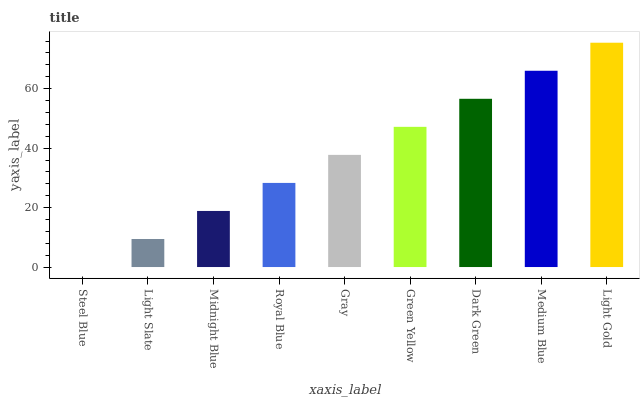Is Steel Blue the minimum?
Answer yes or no. Yes. Is Light Gold the maximum?
Answer yes or no. Yes. Is Light Slate the minimum?
Answer yes or no. No. Is Light Slate the maximum?
Answer yes or no. No. Is Light Slate greater than Steel Blue?
Answer yes or no. Yes. Is Steel Blue less than Light Slate?
Answer yes or no. Yes. Is Steel Blue greater than Light Slate?
Answer yes or no. No. Is Light Slate less than Steel Blue?
Answer yes or no. No. Is Gray the high median?
Answer yes or no. Yes. Is Gray the low median?
Answer yes or no. Yes. Is Dark Green the high median?
Answer yes or no. No. Is Light Slate the low median?
Answer yes or no. No. 